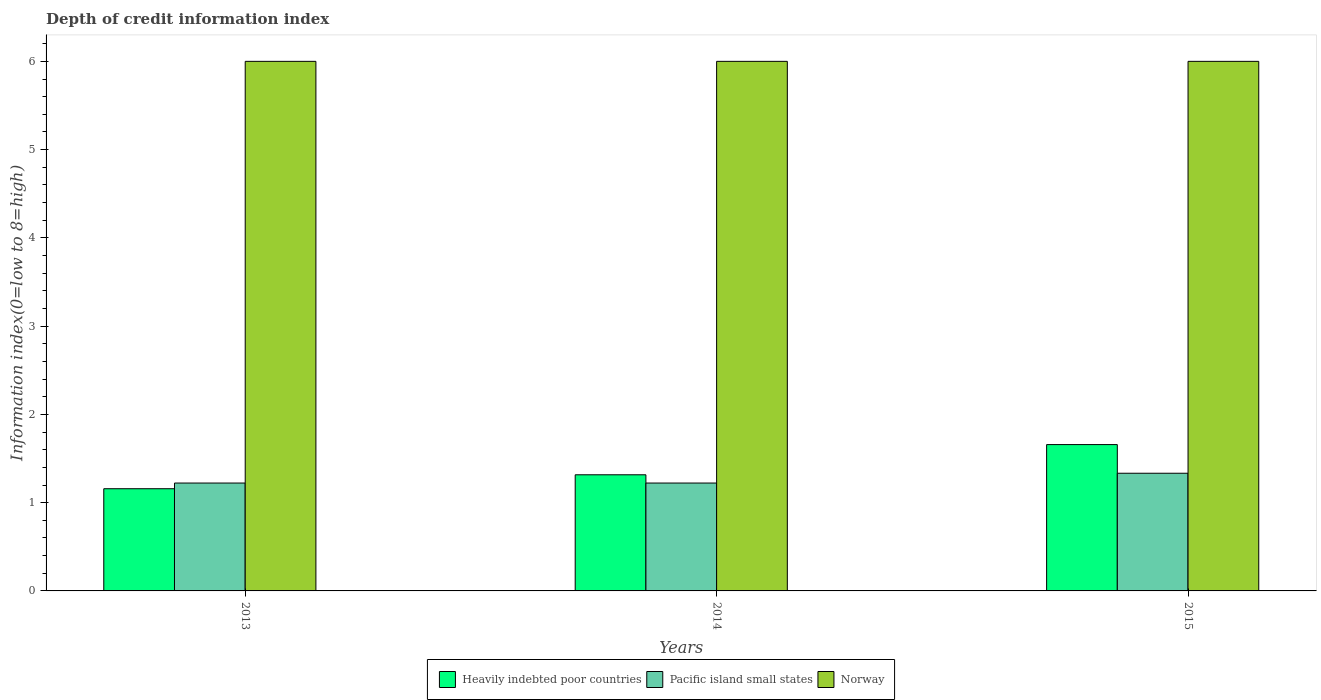How many bars are there on the 2nd tick from the right?
Offer a terse response. 3. What is the label of the 1st group of bars from the left?
Keep it short and to the point. 2013. In how many cases, is the number of bars for a given year not equal to the number of legend labels?
Offer a terse response. 0. What is the information index in Norway in 2014?
Provide a succinct answer. 6. Across all years, what is the maximum information index in Heavily indebted poor countries?
Offer a terse response. 1.66. Across all years, what is the minimum information index in Pacific island small states?
Your response must be concise. 1.22. In which year was the information index in Heavily indebted poor countries maximum?
Provide a short and direct response. 2015. What is the total information index in Pacific island small states in the graph?
Offer a very short reply. 3.78. What is the difference between the information index in Heavily indebted poor countries in 2013 and that in 2014?
Your response must be concise. -0.16. What is the difference between the information index in Pacific island small states in 2015 and the information index in Norway in 2014?
Offer a very short reply. -4.67. What is the average information index in Heavily indebted poor countries per year?
Provide a short and direct response. 1.38. In the year 2014, what is the difference between the information index in Pacific island small states and information index in Heavily indebted poor countries?
Ensure brevity in your answer.  -0.09. In how many years, is the information index in Heavily indebted poor countries greater than 1.4?
Provide a short and direct response. 1. What is the difference between the highest and the second highest information index in Pacific island small states?
Make the answer very short. 0.11. What is the difference between the highest and the lowest information index in Heavily indebted poor countries?
Your answer should be compact. 0.5. In how many years, is the information index in Pacific island small states greater than the average information index in Pacific island small states taken over all years?
Offer a very short reply. 1. What does the 1st bar from the left in 2015 represents?
Provide a succinct answer. Heavily indebted poor countries. What does the 2nd bar from the right in 2014 represents?
Offer a very short reply. Pacific island small states. Is it the case that in every year, the sum of the information index in Heavily indebted poor countries and information index in Pacific island small states is greater than the information index in Norway?
Offer a very short reply. No. How many bars are there?
Offer a very short reply. 9. Are all the bars in the graph horizontal?
Offer a very short reply. No. How many years are there in the graph?
Your answer should be very brief. 3. Are the values on the major ticks of Y-axis written in scientific E-notation?
Your answer should be compact. No. Does the graph contain any zero values?
Give a very brief answer. No. Where does the legend appear in the graph?
Provide a succinct answer. Bottom center. How many legend labels are there?
Your response must be concise. 3. What is the title of the graph?
Offer a terse response. Depth of credit information index. What is the label or title of the X-axis?
Provide a succinct answer. Years. What is the label or title of the Y-axis?
Your answer should be compact. Information index(0=low to 8=high). What is the Information index(0=low to 8=high) of Heavily indebted poor countries in 2013?
Your answer should be compact. 1.16. What is the Information index(0=low to 8=high) of Pacific island small states in 2013?
Provide a succinct answer. 1.22. What is the Information index(0=low to 8=high) of Heavily indebted poor countries in 2014?
Provide a short and direct response. 1.32. What is the Information index(0=low to 8=high) in Pacific island small states in 2014?
Keep it short and to the point. 1.22. What is the Information index(0=low to 8=high) in Heavily indebted poor countries in 2015?
Ensure brevity in your answer.  1.66. What is the Information index(0=low to 8=high) in Pacific island small states in 2015?
Ensure brevity in your answer.  1.33. What is the Information index(0=low to 8=high) in Norway in 2015?
Keep it short and to the point. 6. Across all years, what is the maximum Information index(0=low to 8=high) of Heavily indebted poor countries?
Provide a succinct answer. 1.66. Across all years, what is the maximum Information index(0=low to 8=high) of Pacific island small states?
Keep it short and to the point. 1.33. Across all years, what is the maximum Information index(0=low to 8=high) in Norway?
Offer a very short reply. 6. Across all years, what is the minimum Information index(0=low to 8=high) of Heavily indebted poor countries?
Your response must be concise. 1.16. Across all years, what is the minimum Information index(0=low to 8=high) in Pacific island small states?
Ensure brevity in your answer.  1.22. What is the total Information index(0=low to 8=high) in Heavily indebted poor countries in the graph?
Offer a terse response. 4.13. What is the total Information index(0=low to 8=high) of Pacific island small states in the graph?
Your answer should be compact. 3.78. What is the difference between the Information index(0=low to 8=high) in Heavily indebted poor countries in 2013 and that in 2014?
Your answer should be compact. -0.16. What is the difference between the Information index(0=low to 8=high) in Pacific island small states in 2013 and that in 2014?
Offer a very short reply. 0. What is the difference between the Information index(0=low to 8=high) in Heavily indebted poor countries in 2013 and that in 2015?
Your answer should be very brief. -0.5. What is the difference between the Information index(0=low to 8=high) in Pacific island small states in 2013 and that in 2015?
Make the answer very short. -0.11. What is the difference between the Information index(0=low to 8=high) in Norway in 2013 and that in 2015?
Your response must be concise. 0. What is the difference between the Information index(0=low to 8=high) in Heavily indebted poor countries in 2014 and that in 2015?
Your answer should be compact. -0.34. What is the difference between the Information index(0=low to 8=high) of Pacific island small states in 2014 and that in 2015?
Keep it short and to the point. -0.11. What is the difference between the Information index(0=low to 8=high) of Norway in 2014 and that in 2015?
Provide a short and direct response. 0. What is the difference between the Information index(0=low to 8=high) of Heavily indebted poor countries in 2013 and the Information index(0=low to 8=high) of Pacific island small states in 2014?
Ensure brevity in your answer.  -0.06. What is the difference between the Information index(0=low to 8=high) of Heavily indebted poor countries in 2013 and the Information index(0=low to 8=high) of Norway in 2014?
Offer a terse response. -4.84. What is the difference between the Information index(0=low to 8=high) of Pacific island small states in 2013 and the Information index(0=low to 8=high) of Norway in 2014?
Offer a terse response. -4.78. What is the difference between the Information index(0=low to 8=high) of Heavily indebted poor countries in 2013 and the Information index(0=low to 8=high) of Pacific island small states in 2015?
Keep it short and to the point. -0.18. What is the difference between the Information index(0=low to 8=high) of Heavily indebted poor countries in 2013 and the Information index(0=low to 8=high) of Norway in 2015?
Offer a terse response. -4.84. What is the difference between the Information index(0=low to 8=high) of Pacific island small states in 2013 and the Information index(0=low to 8=high) of Norway in 2015?
Make the answer very short. -4.78. What is the difference between the Information index(0=low to 8=high) of Heavily indebted poor countries in 2014 and the Information index(0=low to 8=high) of Pacific island small states in 2015?
Make the answer very short. -0.02. What is the difference between the Information index(0=low to 8=high) in Heavily indebted poor countries in 2014 and the Information index(0=low to 8=high) in Norway in 2015?
Give a very brief answer. -4.68. What is the difference between the Information index(0=low to 8=high) of Pacific island small states in 2014 and the Information index(0=low to 8=high) of Norway in 2015?
Provide a short and direct response. -4.78. What is the average Information index(0=low to 8=high) of Heavily indebted poor countries per year?
Provide a short and direct response. 1.38. What is the average Information index(0=low to 8=high) of Pacific island small states per year?
Make the answer very short. 1.26. In the year 2013, what is the difference between the Information index(0=low to 8=high) of Heavily indebted poor countries and Information index(0=low to 8=high) of Pacific island small states?
Provide a short and direct response. -0.06. In the year 2013, what is the difference between the Information index(0=low to 8=high) in Heavily indebted poor countries and Information index(0=low to 8=high) in Norway?
Your answer should be very brief. -4.84. In the year 2013, what is the difference between the Information index(0=low to 8=high) of Pacific island small states and Information index(0=low to 8=high) of Norway?
Offer a very short reply. -4.78. In the year 2014, what is the difference between the Information index(0=low to 8=high) in Heavily indebted poor countries and Information index(0=low to 8=high) in Pacific island small states?
Give a very brief answer. 0.09. In the year 2014, what is the difference between the Information index(0=low to 8=high) in Heavily indebted poor countries and Information index(0=low to 8=high) in Norway?
Your response must be concise. -4.68. In the year 2014, what is the difference between the Information index(0=low to 8=high) in Pacific island small states and Information index(0=low to 8=high) in Norway?
Keep it short and to the point. -4.78. In the year 2015, what is the difference between the Information index(0=low to 8=high) in Heavily indebted poor countries and Information index(0=low to 8=high) in Pacific island small states?
Provide a short and direct response. 0.32. In the year 2015, what is the difference between the Information index(0=low to 8=high) in Heavily indebted poor countries and Information index(0=low to 8=high) in Norway?
Ensure brevity in your answer.  -4.34. In the year 2015, what is the difference between the Information index(0=low to 8=high) of Pacific island small states and Information index(0=low to 8=high) of Norway?
Your answer should be very brief. -4.67. What is the ratio of the Information index(0=low to 8=high) in Pacific island small states in 2013 to that in 2014?
Provide a succinct answer. 1. What is the ratio of the Information index(0=low to 8=high) in Heavily indebted poor countries in 2013 to that in 2015?
Provide a short and direct response. 0.7. What is the ratio of the Information index(0=low to 8=high) in Heavily indebted poor countries in 2014 to that in 2015?
Your answer should be very brief. 0.79. What is the difference between the highest and the second highest Information index(0=low to 8=high) of Heavily indebted poor countries?
Provide a succinct answer. 0.34. What is the difference between the highest and the second highest Information index(0=low to 8=high) in Pacific island small states?
Your response must be concise. 0.11. What is the difference between the highest and the lowest Information index(0=low to 8=high) of Heavily indebted poor countries?
Ensure brevity in your answer.  0.5. What is the difference between the highest and the lowest Information index(0=low to 8=high) of Pacific island small states?
Your response must be concise. 0.11. 